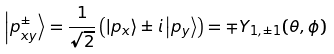<formula> <loc_0><loc_0><loc_500><loc_500>\left | p _ { x y } ^ { \pm } \right \rangle = \frac { 1 } { \sqrt { 2 } } \left ( \left | p _ { x } \right \rangle \pm i \left | p _ { y } \right \rangle \right ) = \mp Y _ { 1 , \pm 1 } ( \theta , \phi )</formula> 